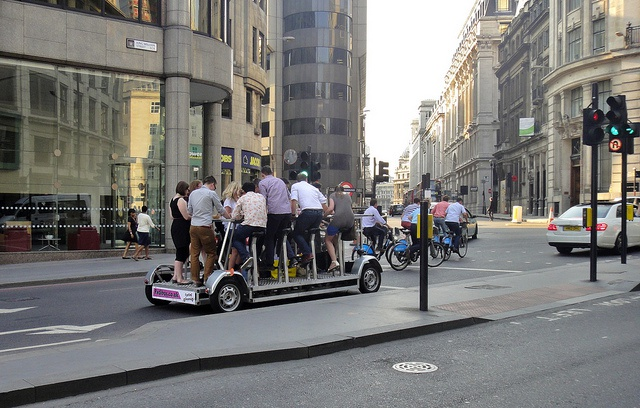Describe the objects in this image and their specific colors. I can see car in gray, darkgray, black, and lightgray tones, people in gray, black, and darkgray tones, people in gray, black, darkgray, and maroon tones, people in gray, black, and darkgray tones, and people in gray, black, lavender, and darkgray tones in this image. 